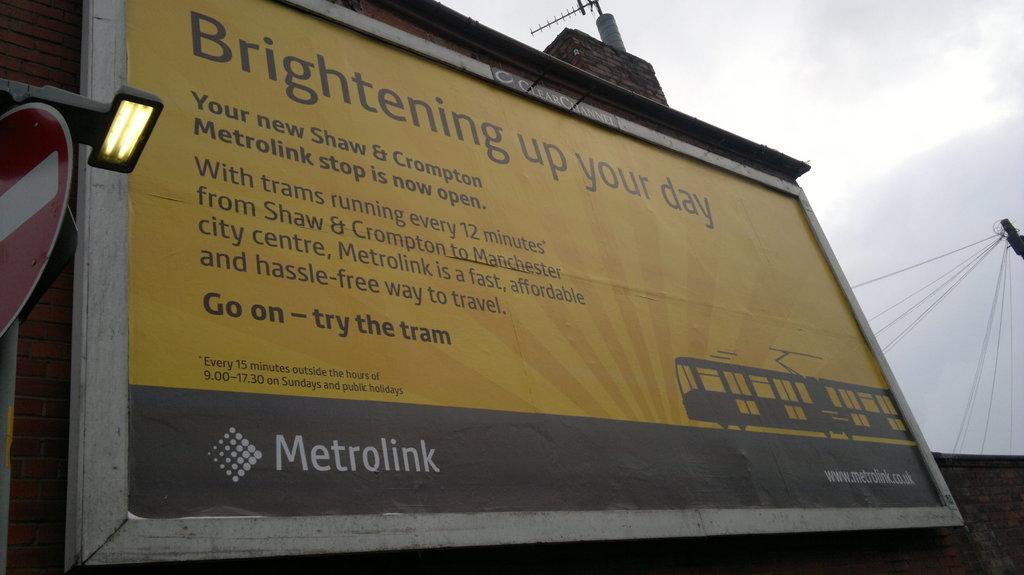What is the company name on the billboard?
Your answer should be very brief. Metrolink. 